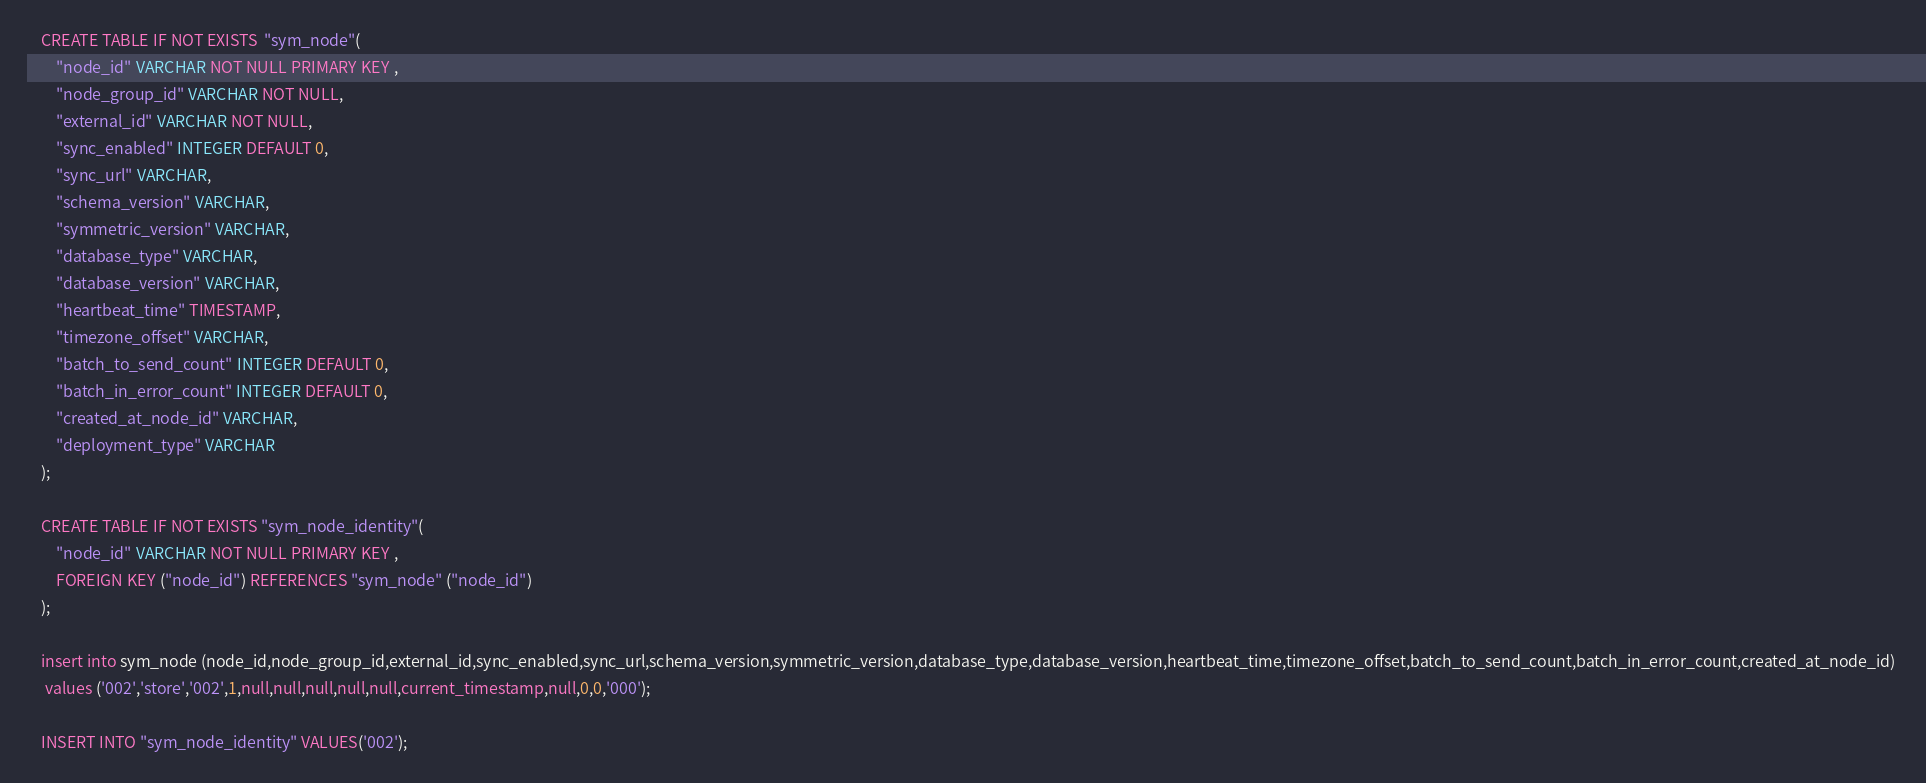<code> <loc_0><loc_0><loc_500><loc_500><_SQL_>	CREATE TABLE IF NOT EXISTS  "sym_node"(
		"node_id" VARCHAR NOT NULL PRIMARY KEY ,
		"node_group_id" VARCHAR NOT NULL,
		"external_id" VARCHAR NOT NULL,
		"sync_enabled" INTEGER DEFAULT 0,
		"sync_url" VARCHAR,
		"schema_version" VARCHAR,
		"symmetric_version" VARCHAR,
		"database_type" VARCHAR,
		"database_version" VARCHAR,
		"heartbeat_time" TIMESTAMP,
		"timezone_offset" VARCHAR,
		"batch_to_send_count" INTEGER DEFAULT 0,
		"batch_in_error_count" INTEGER DEFAULT 0,
		"created_at_node_id" VARCHAR,
		"deployment_type" VARCHAR
	);

	CREATE TABLE IF NOT EXISTS "sym_node_identity"(
		"node_id" VARCHAR NOT NULL PRIMARY KEY ,
		FOREIGN KEY ("node_id") REFERENCES "sym_node" ("node_id")
	);

	insert into sym_node (node_id,node_group_id,external_id,sync_enabled,sync_url,schema_version,symmetric_version,database_type,database_version,heartbeat_time,timezone_offset,batch_to_send_count,batch_in_error_count,created_at_node_id) 
	 values ('002','store','002',1,null,null,null,null,null,current_timestamp,null,0,0,'000');

	INSERT INTO "sym_node_identity" VALUES('002');
</code> 